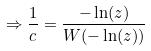<formula> <loc_0><loc_0><loc_500><loc_500>\Rightarrow \frac { 1 } { c } = \frac { - \ln ( z ) } { W ( - \ln ( z ) ) }</formula> 